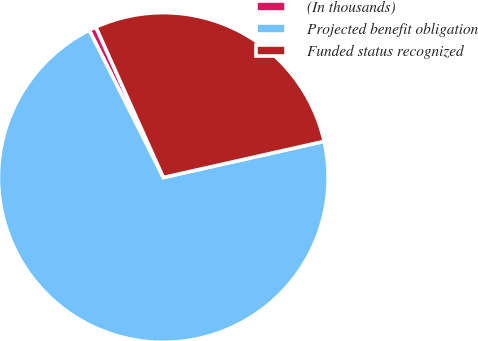<chart> <loc_0><loc_0><loc_500><loc_500><pie_chart><fcel>(In thousands)<fcel>Projected benefit obligation<fcel>Funded status recognized<nl><fcel>0.71%<fcel>71.1%<fcel>28.19%<nl></chart> 